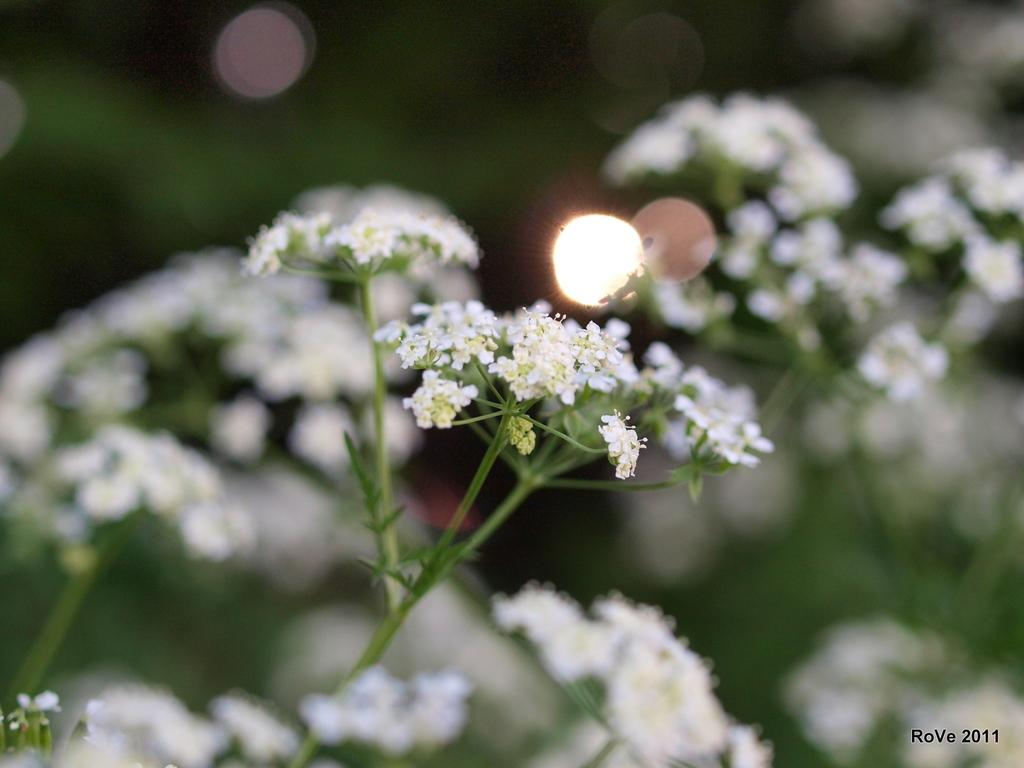What is in the foreground of the image? There are flowers in the foreground of the image. What are the flowers attached to? The flowers are on a plant. Can you describe the background of the image? The background of the image is blurred. What type of playground equipment can be seen in the background of the image? There is no playground equipment visible in the image; the background is blurred. How much salt is present on the ground in the image? There is no salt or ground present in the image; it features flowers in the foreground and a blurred background. 